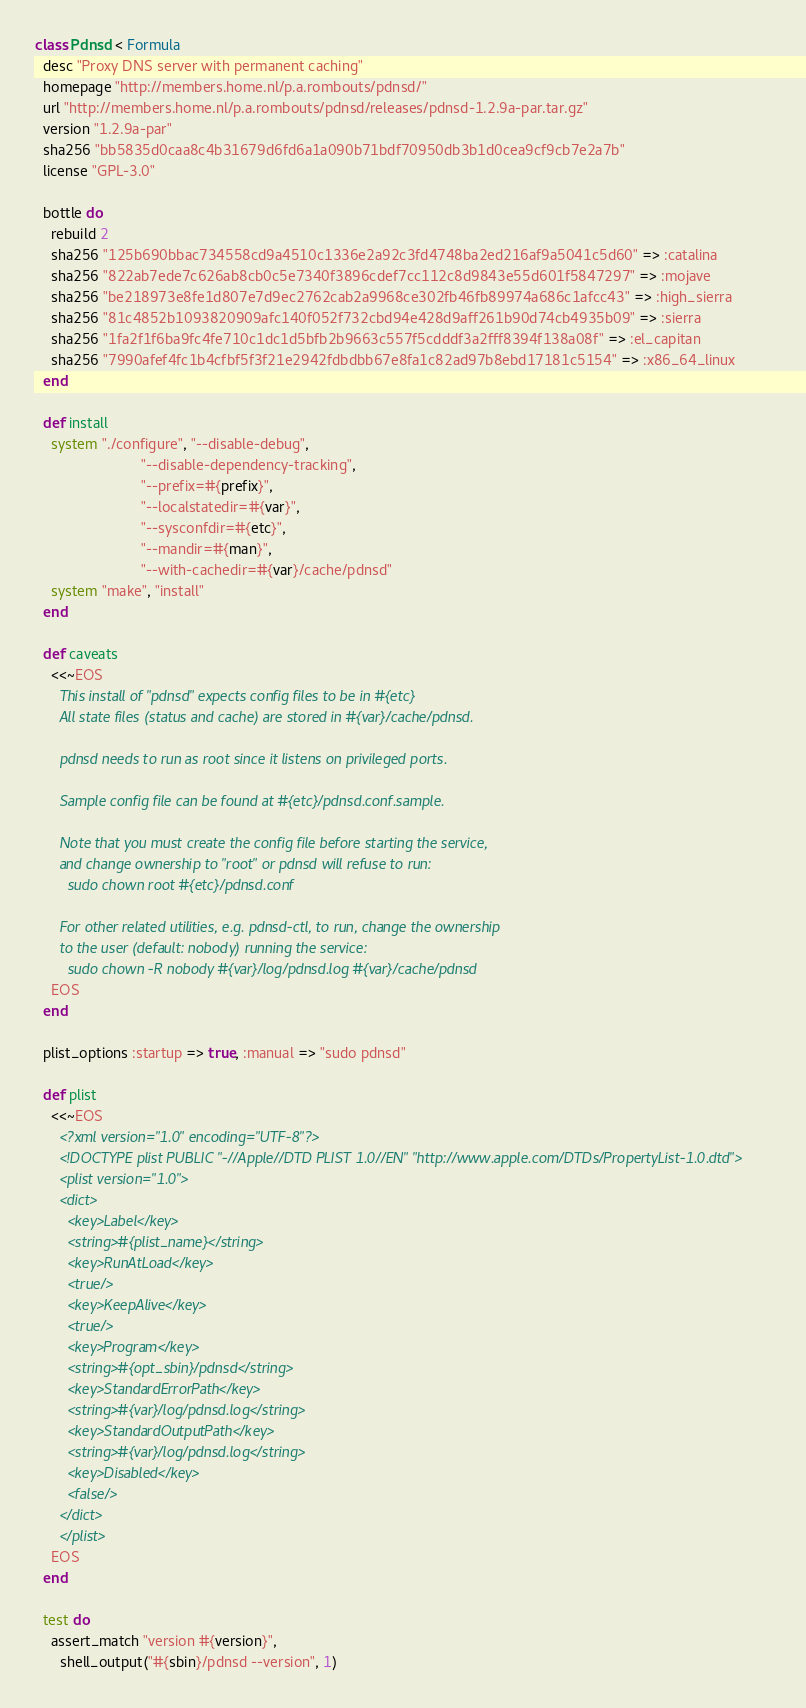Convert code to text. <code><loc_0><loc_0><loc_500><loc_500><_Ruby_>class Pdnsd < Formula
  desc "Proxy DNS server with permanent caching"
  homepage "http://members.home.nl/p.a.rombouts/pdnsd/"
  url "http://members.home.nl/p.a.rombouts/pdnsd/releases/pdnsd-1.2.9a-par.tar.gz"
  version "1.2.9a-par"
  sha256 "bb5835d0caa8c4b31679d6fd6a1a090b71bdf70950db3b1d0cea9cf9cb7e2a7b"
  license "GPL-3.0"

  bottle do
    rebuild 2
    sha256 "125b690bbac734558cd9a4510c1336e2a92c3fd4748ba2ed216af9a5041c5d60" => :catalina
    sha256 "822ab7ede7c626ab8cb0c5e7340f3896cdef7cc112c8d9843e55d601f5847297" => :mojave
    sha256 "be218973e8fe1d807e7d9ec2762cab2a9968ce302fb46fb89974a686c1afcc43" => :high_sierra
    sha256 "81c4852b1093820909afc140f052f732cbd94e428d9aff261b90d74cb4935b09" => :sierra
    sha256 "1fa2f1f6ba9fc4fe710c1dc1d5bfb2b9663c557f5cdddf3a2fff8394f138a08f" => :el_capitan
    sha256 "7990afef4fc1b4cfbf5f3f21e2942fdbdbb67e8fa1c82ad97b8ebd17181c5154" => :x86_64_linux
  end

  def install
    system "./configure", "--disable-debug",
                          "--disable-dependency-tracking",
                          "--prefix=#{prefix}",
                          "--localstatedir=#{var}",
                          "--sysconfdir=#{etc}",
                          "--mandir=#{man}",
                          "--with-cachedir=#{var}/cache/pdnsd"
    system "make", "install"
  end

  def caveats
    <<~EOS
      This install of "pdnsd" expects config files to be in #{etc}
      All state files (status and cache) are stored in #{var}/cache/pdnsd.

      pdnsd needs to run as root since it listens on privileged ports.

      Sample config file can be found at #{etc}/pdnsd.conf.sample.

      Note that you must create the config file before starting the service,
      and change ownership to "root" or pdnsd will refuse to run:
        sudo chown root #{etc}/pdnsd.conf

      For other related utilities, e.g. pdnsd-ctl, to run, change the ownership
      to the user (default: nobody) running the service:
        sudo chown -R nobody #{var}/log/pdnsd.log #{var}/cache/pdnsd
    EOS
  end

  plist_options :startup => true, :manual => "sudo pdnsd"

  def plist
    <<~EOS
      <?xml version="1.0" encoding="UTF-8"?>
      <!DOCTYPE plist PUBLIC "-//Apple//DTD PLIST 1.0//EN" "http://www.apple.com/DTDs/PropertyList-1.0.dtd">
      <plist version="1.0">
      <dict>
        <key>Label</key>
        <string>#{plist_name}</string>
        <key>RunAtLoad</key>
        <true/>
        <key>KeepAlive</key>
        <true/>
        <key>Program</key>
        <string>#{opt_sbin}/pdnsd</string>
        <key>StandardErrorPath</key>
        <string>#{var}/log/pdnsd.log</string>
        <key>StandardOutputPath</key>
        <string>#{var}/log/pdnsd.log</string>
        <key>Disabled</key>
        <false/>
      </dict>
      </plist>
    EOS
  end

  test do
    assert_match "version #{version}",
      shell_output("#{sbin}/pdnsd --version", 1)</code> 